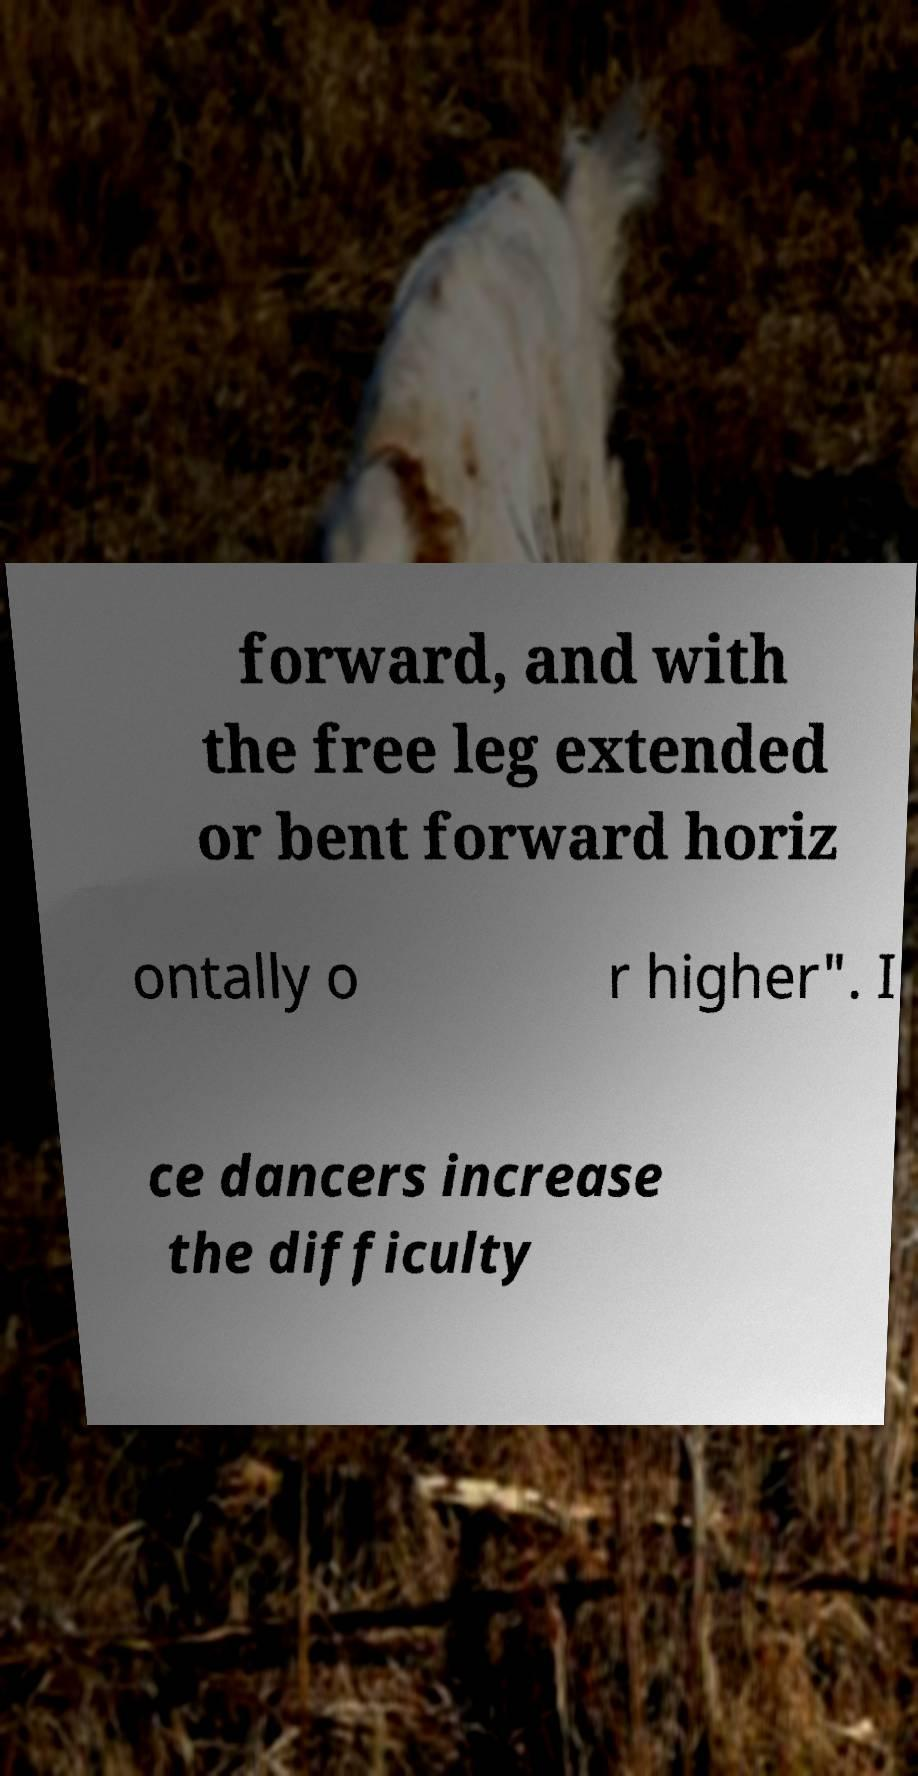Can you accurately transcribe the text from the provided image for me? forward, and with the free leg extended or bent forward horiz ontally o r higher". I ce dancers increase the difficulty 